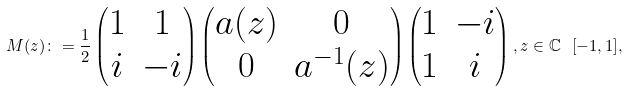Convert formula to latex. <formula><loc_0><loc_0><loc_500><loc_500>M ( z ) \colon = \frac { 1 } { 2 } \begin{pmatrix} 1 & 1 \\ i & - i \end{pmatrix} \begin{pmatrix} a ( z ) & 0 \\ 0 & a ^ { - 1 } ( z ) \end{pmatrix} \begin{pmatrix} 1 & - i \\ 1 & i \end{pmatrix} , z \in \mathbb { C } \ [ - 1 , 1 ] ,</formula> 